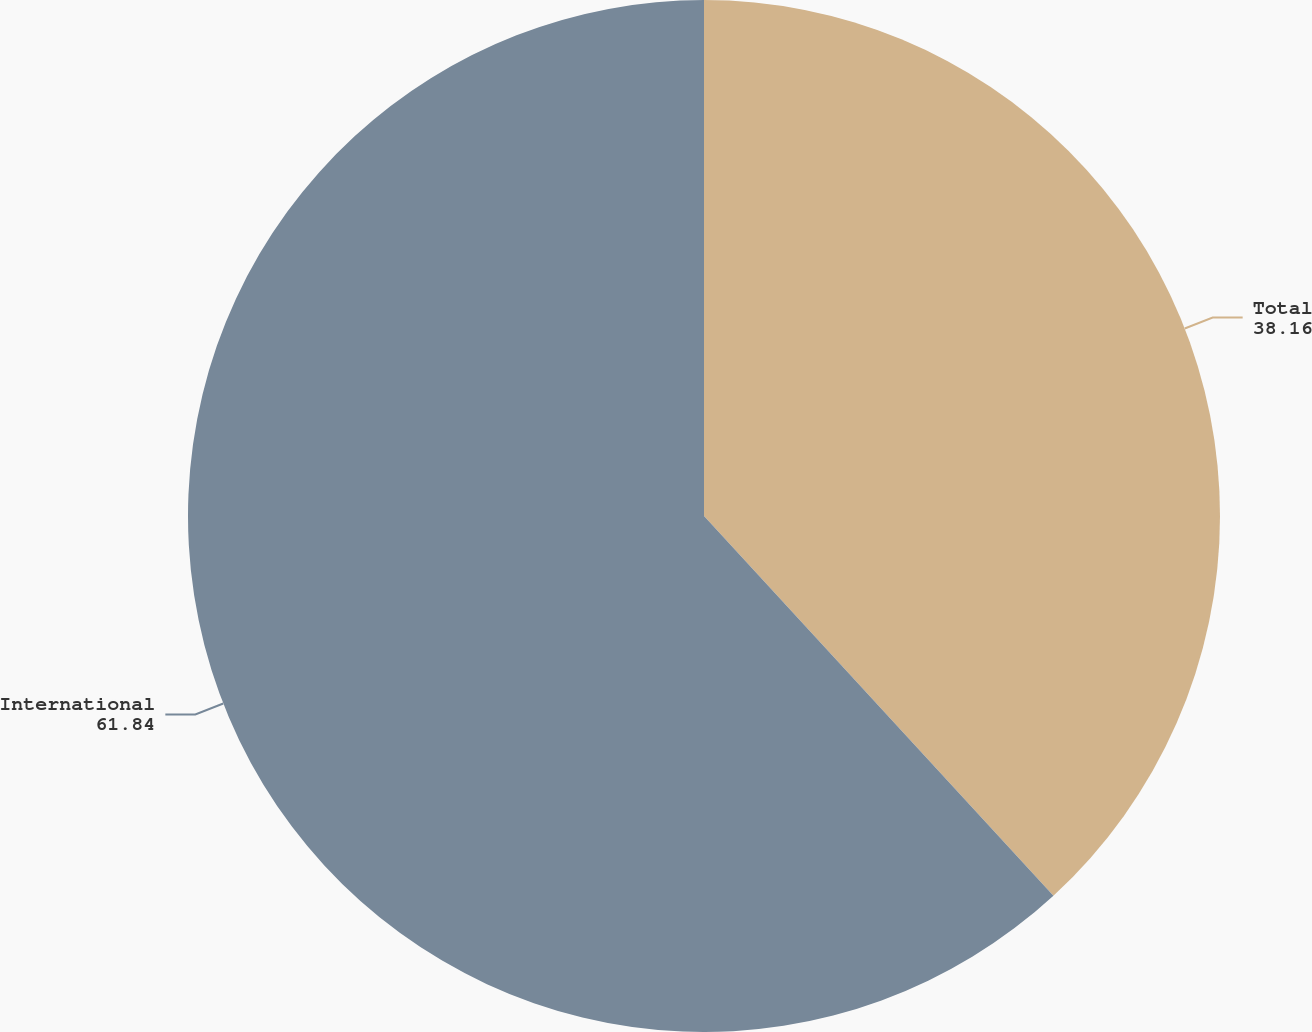Convert chart to OTSL. <chart><loc_0><loc_0><loc_500><loc_500><pie_chart><fcel>Total<fcel>International<nl><fcel>38.16%<fcel>61.84%<nl></chart> 